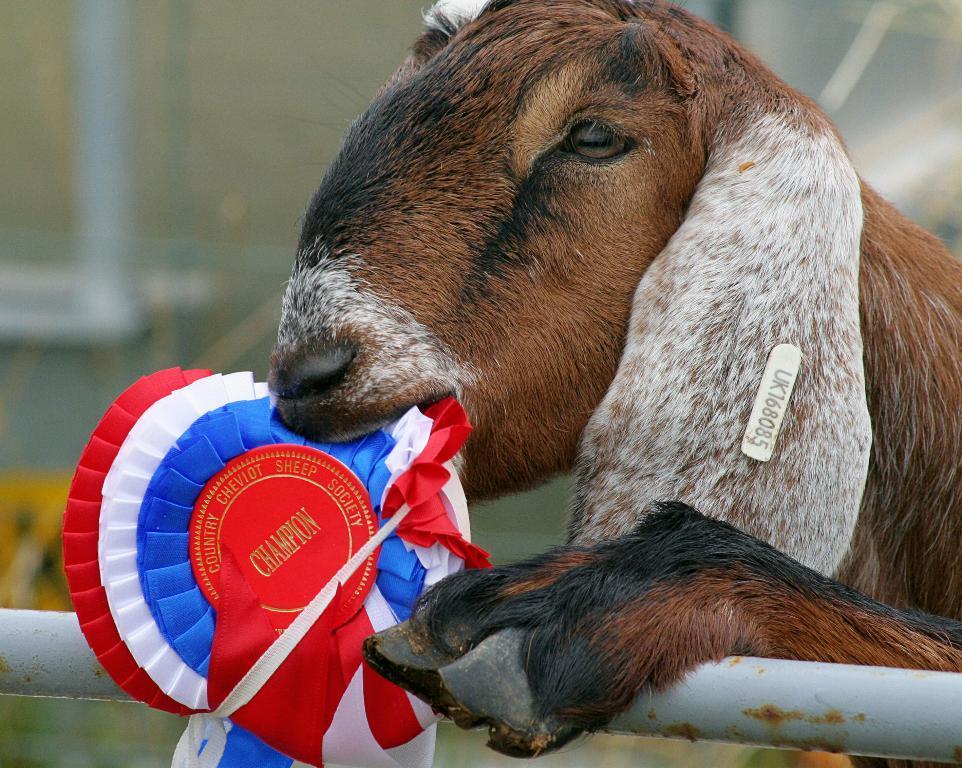Could you give a brief overview of what you see in this image? In this image I can see an animal which is in white, brown and black color. In-front of an animal I can see the rod and the badge which is in white, blue and red color. I can see there is a blurred background. 